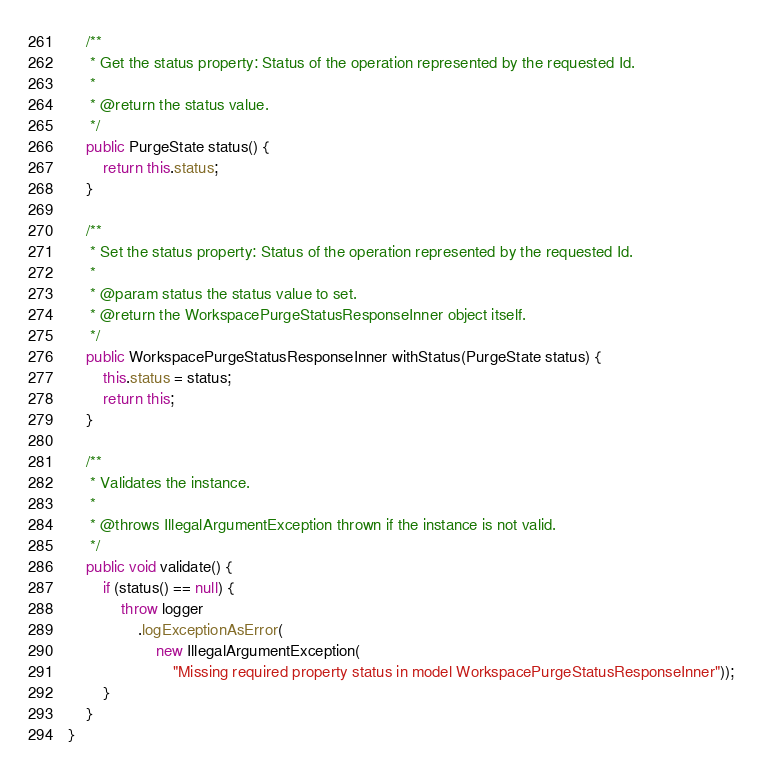<code> <loc_0><loc_0><loc_500><loc_500><_Java_>
    /**
     * Get the status property: Status of the operation represented by the requested Id.
     *
     * @return the status value.
     */
    public PurgeState status() {
        return this.status;
    }

    /**
     * Set the status property: Status of the operation represented by the requested Id.
     *
     * @param status the status value to set.
     * @return the WorkspacePurgeStatusResponseInner object itself.
     */
    public WorkspacePurgeStatusResponseInner withStatus(PurgeState status) {
        this.status = status;
        return this;
    }

    /**
     * Validates the instance.
     *
     * @throws IllegalArgumentException thrown if the instance is not valid.
     */
    public void validate() {
        if (status() == null) {
            throw logger
                .logExceptionAsError(
                    new IllegalArgumentException(
                        "Missing required property status in model WorkspacePurgeStatusResponseInner"));
        }
    }
}
</code> 